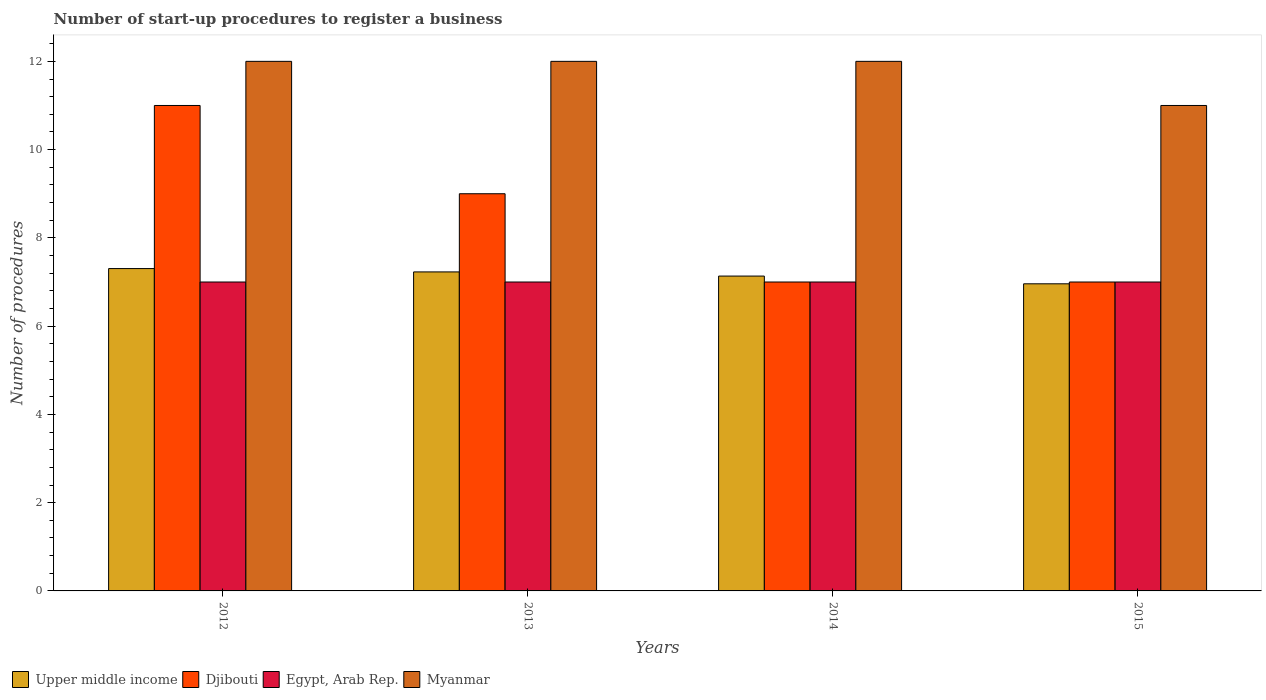How many groups of bars are there?
Provide a succinct answer. 4. What is the label of the 3rd group of bars from the left?
Give a very brief answer. 2014. In how many cases, is the number of bars for a given year not equal to the number of legend labels?
Provide a succinct answer. 0. What is the number of procedures required to register a business in Myanmar in 2012?
Ensure brevity in your answer.  12. Across all years, what is the maximum number of procedures required to register a business in Egypt, Arab Rep.?
Make the answer very short. 7. Across all years, what is the minimum number of procedures required to register a business in Myanmar?
Make the answer very short. 11. In which year was the number of procedures required to register a business in Djibouti maximum?
Offer a terse response. 2012. In which year was the number of procedures required to register a business in Myanmar minimum?
Offer a terse response. 2015. What is the total number of procedures required to register a business in Egypt, Arab Rep. in the graph?
Provide a succinct answer. 28. What is the difference between the number of procedures required to register a business in Egypt, Arab Rep. in 2013 and that in 2015?
Provide a succinct answer. 0. What is the difference between the number of procedures required to register a business in Upper middle income in 2014 and the number of procedures required to register a business in Myanmar in 2012?
Ensure brevity in your answer.  -4.87. What is the average number of procedures required to register a business in Egypt, Arab Rep. per year?
Provide a succinct answer. 7. In how many years, is the number of procedures required to register a business in Egypt, Arab Rep. greater than 6.4?
Your answer should be compact. 4. What is the ratio of the number of procedures required to register a business in Myanmar in 2013 to that in 2015?
Provide a short and direct response. 1.09. Is the difference between the number of procedures required to register a business in Djibouti in 2012 and 2014 greater than the difference between the number of procedures required to register a business in Egypt, Arab Rep. in 2012 and 2014?
Ensure brevity in your answer.  Yes. What is the difference between the highest and the second highest number of procedures required to register a business in Upper middle income?
Provide a short and direct response. 0.08. In how many years, is the number of procedures required to register a business in Myanmar greater than the average number of procedures required to register a business in Myanmar taken over all years?
Provide a succinct answer. 3. Is the sum of the number of procedures required to register a business in Egypt, Arab Rep. in 2012 and 2015 greater than the maximum number of procedures required to register a business in Myanmar across all years?
Offer a very short reply. Yes. What does the 1st bar from the left in 2014 represents?
Ensure brevity in your answer.  Upper middle income. What does the 3rd bar from the right in 2014 represents?
Give a very brief answer. Djibouti. How many bars are there?
Ensure brevity in your answer.  16. How many years are there in the graph?
Ensure brevity in your answer.  4. What is the difference between two consecutive major ticks on the Y-axis?
Your answer should be very brief. 2. Does the graph contain grids?
Give a very brief answer. No. Where does the legend appear in the graph?
Your response must be concise. Bottom left. What is the title of the graph?
Provide a short and direct response. Number of start-up procedures to register a business. What is the label or title of the Y-axis?
Keep it short and to the point. Number of procedures. What is the Number of procedures of Upper middle income in 2012?
Give a very brief answer. 7.3. What is the Number of procedures in Myanmar in 2012?
Provide a short and direct response. 12. What is the Number of procedures of Upper middle income in 2013?
Your answer should be very brief. 7.23. What is the Number of procedures in Djibouti in 2013?
Offer a terse response. 9. What is the Number of procedures of Egypt, Arab Rep. in 2013?
Your answer should be compact. 7. What is the Number of procedures of Upper middle income in 2014?
Give a very brief answer. 7.13. What is the Number of procedures in Djibouti in 2014?
Offer a terse response. 7. What is the Number of procedures of Myanmar in 2014?
Make the answer very short. 12. What is the Number of procedures in Upper middle income in 2015?
Keep it short and to the point. 6.96. What is the Number of procedures of Egypt, Arab Rep. in 2015?
Keep it short and to the point. 7. What is the Number of procedures in Myanmar in 2015?
Your answer should be very brief. 11. Across all years, what is the maximum Number of procedures in Upper middle income?
Offer a terse response. 7.3. Across all years, what is the maximum Number of procedures of Egypt, Arab Rep.?
Provide a succinct answer. 7. Across all years, what is the maximum Number of procedures in Myanmar?
Your answer should be compact. 12. Across all years, what is the minimum Number of procedures in Upper middle income?
Your answer should be compact. 6.96. Across all years, what is the minimum Number of procedures of Djibouti?
Your response must be concise. 7. Across all years, what is the minimum Number of procedures of Myanmar?
Provide a succinct answer. 11. What is the total Number of procedures in Upper middle income in the graph?
Provide a short and direct response. 28.63. What is the total Number of procedures in Egypt, Arab Rep. in the graph?
Your answer should be very brief. 28. What is the difference between the Number of procedures in Upper middle income in 2012 and that in 2013?
Give a very brief answer. 0.08. What is the difference between the Number of procedures of Upper middle income in 2012 and that in 2014?
Ensure brevity in your answer.  0.17. What is the difference between the Number of procedures of Egypt, Arab Rep. in 2012 and that in 2014?
Provide a short and direct response. 0. What is the difference between the Number of procedures in Myanmar in 2012 and that in 2014?
Your answer should be compact. 0. What is the difference between the Number of procedures of Upper middle income in 2012 and that in 2015?
Offer a terse response. 0.35. What is the difference between the Number of procedures in Djibouti in 2012 and that in 2015?
Your answer should be compact. 4. What is the difference between the Number of procedures in Egypt, Arab Rep. in 2012 and that in 2015?
Your answer should be very brief. 0. What is the difference between the Number of procedures in Upper middle income in 2013 and that in 2014?
Your answer should be very brief. 0.09. What is the difference between the Number of procedures in Djibouti in 2013 and that in 2014?
Ensure brevity in your answer.  2. What is the difference between the Number of procedures of Upper middle income in 2013 and that in 2015?
Offer a very short reply. 0.27. What is the difference between the Number of procedures of Djibouti in 2013 and that in 2015?
Your answer should be compact. 2. What is the difference between the Number of procedures of Myanmar in 2013 and that in 2015?
Give a very brief answer. 1. What is the difference between the Number of procedures in Upper middle income in 2014 and that in 2015?
Your answer should be compact. 0.18. What is the difference between the Number of procedures of Egypt, Arab Rep. in 2014 and that in 2015?
Your answer should be compact. 0. What is the difference between the Number of procedures in Upper middle income in 2012 and the Number of procedures in Djibouti in 2013?
Give a very brief answer. -1.7. What is the difference between the Number of procedures in Upper middle income in 2012 and the Number of procedures in Egypt, Arab Rep. in 2013?
Your response must be concise. 0.3. What is the difference between the Number of procedures of Upper middle income in 2012 and the Number of procedures of Myanmar in 2013?
Provide a succinct answer. -4.7. What is the difference between the Number of procedures of Djibouti in 2012 and the Number of procedures of Myanmar in 2013?
Ensure brevity in your answer.  -1. What is the difference between the Number of procedures in Egypt, Arab Rep. in 2012 and the Number of procedures in Myanmar in 2013?
Provide a short and direct response. -5. What is the difference between the Number of procedures of Upper middle income in 2012 and the Number of procedures of Djibouti in 2014?
Ensure brevity in your answer.  0.3. What is the difference between the Number of procedures in Upper middle income in 2012 and the Number of procedures in Egypt, Arab Rep. in 2014?
Keep it short and to the point. 0.3. What is the difference between the Number of procedures of Upper middle income in 2012 and the Number of procedures of Myanmar in 2014?
Keep it short and to the point. -4.7. What is the difference between the Number of procedures in Djibouti in 2012 and the Number of procedures in Myanmar in 2014?
Provide a succinct answer. -1. What is the difference between the Number of procedures in Egypt, Arab Rep. in 2012 and the Number of procedures in Myanmar in 2014?
Offer a very short reply. -5. What is the difference between the Number of procedures in Upper middle income in 2012 and the Number of procedures in Djibouti in 2015?
Offer a very short reply. 0.3. What is the difference between the Number of procedures of Upper middle income in 2012 and the Number of procedures of Egypt, Arab Rep. in 2015?
Offer a terse response. 0.3. What is the difference between the Number of procedures in Upper middle income in 2012 and the Number of procedures in Myanmar in 2015?
Your response must be concise. -3.7. What is the difference between the Number of procedures in Djibouti in 2012 and the Number of procedures in Egypt, Arab Rep. in 2015?
Provide a succinct answer. 4. What is the difference between the Number of procedures of Djibouti in 2012 and the Number of procedures of Myanmar in 2015?
Make the answer very short. 0. What is the difference between the Number of procedures of Egypt, Arab Rep. in 2012 and the Number of procedures of Myanmar in 2015?
Provide a short and direct response. -4. What is the difference between the Number of procedures of Upper middle income in 2013 and the Number of procedures of Djibouti in 2014?
Provide a short and direct response. 0.23. What is the difference between the Number of procedures of Upper middle income in 2013 and the Number of procedures of Egypt, Arab Rep. in 2014?
Provide a short and direct response. 0.23. What is the difference between the Number of procedures of Upper middle income in 2013 and the Number of procedures of Myanmar in 2014?
Ensure brevity in your answer.  -4.77. What is the difference between the Number of procedures of Djibouti in 2013 and the Number of procedures of Egypt, Arab Rep. in 2014?
Ensure brevity in your answer.  2. What is the difference between the Number of procedures of Upper middle income in 2013 and the Number of procedures of Djibouti in 2015?
Your response must be concise. 0.23. What is the difference between the Number of procedures of Upper middle income in 2013 and the Number of procedures of Egypt, Arab Rep. in 2015?
Your answer should be very brief. 0.23. What is the difference between the Number of procedures of Upper middle income in 2013 and the Number of procedures of Myanmar in 2015?
Your answer should be compact. -3.77. What is the difference between the Number of procedures in Djibouti in 2013 and the Number of procedures in Myanmar in 2015?
Your answer should be very brief. -2. What is the difference between the Number of procedures in Upper middle income in 2014 and the Number of procedures in Djibouti in 2015?
Ensure brevity in your answer.  0.13. What is the difference between the Number of procedures of Upper middle income in 2014 and the Number of procedures of Egypt, Arab Rep. in 2015?
Keep it short and to the point. 0.13. What is the difference between the Number of procedures in Upper middle income in 2014 and the Number of procedures in Myanmar in 2015?
Offer a very short reply. -3.87. What is the difference between the Number of procedures in Djibouti in 2014 and the Number of procedures in Egypt, Arab Rep. in 2015?
Make the answer very short. 0. What is the average Number of procedures in Upper middle income per year?
Make the answer very short. 7.16. What is the average Number of procedures in Egypt, Arab Rep. per year?
Offer a terse response. 7. What is the average Number of procedures of Myanmar per year?
Your response must be concise. 11.75. In the year 2012, what is the difference between the Number of procedures in Upper middle income and Number of procedures in Djibouti?
Provide a short and direct response. -3.7. In the year 2012, what is the difference between the Number of procedures in Upper middle income and Number of procedures in Egypt, Arab Rep.?
Provide a short and direct response. 0.3. In the year 2012, what is the difference between the Number of procedures of Upper middle income and Number of procedures of Myanmar?
Keep it short and to the point. -4.7. In the year 2012, what is the difference between the Number of procedures of Djibouti and Number of procedures of Egypt, Arab Rep.?
Provide a succinct answer. 4. In the year 2012, what is the difference between the Number of procedures of Djibouti and Number of procedures of Myanmar?
Your response must be concise. -1. In the year 2013, what is the difference between the Number of procedures in Upper middle income and Number of procedures in Djibouti?
Offer a terse response. -1.77. In the year 2013, what is the difference between the Number of procedures of Upper middle income and Number of procedures of Egypt, Arab Rep.?
Your answer should be very brief. 0.23. In the year 2013, what is the difference between the Number of procedures in Upper middle income and Number of procedures in Myanmar?
Provide a succinct answer. -4.77. In the year 2013, what is the difference between the Number of procedures of Djibouti and Number of procedures of Myanmar?
Give a very brief answer. -3. In the year 2013, what is the difference between the Number of procedures in Egypt, Arab Rep. and Number of procedures in Myanmar?
Your answer should be compact. -5. In the year 2014, what is the difference between the Number of procedures of Upper middle income and Number of procedures of Djibouti?
Your response must be concise. 0.13. In the year 2014, what is the difference between the Number of procedures in Upper middle income and Number of procedures in Egypt, Arab Rep.?
Offer a very short reply. 0.13. In the year 2014, what is the difference between the Number of procedures in Upper middle income and Number of procedures in Myanmar?
Ensure brevity in your answer.  -4.87. In the year 2014, what is the difference between the Number of procedures in Djibouti and Number of procedures in Myanmar?
Make the answer very short. -5. In the year 2014, what is the difference between the Number of procedures of Egypt, Arab Rep. and Number of procedures of Myanmar?
Offer a terse response. -5. In the year 2015, what is the difference between the Number of procedures of Upper middle income and Number of procedures of Djibouti?
Your answer should be very brief. -0.04. In the year 2015, what is the difference between the Number of procedures in Upper middle income and Number of procedures in Egypt, Arab Rep.?
Your answer should be very brief. -0.04. In the year 2015, what is the difference between the Number of procedures of Upper middle income and Number of procedures of Myanmar?
Provide a short and direct response. -4.04. In the year 2015, what is the difference between the Number of procedures in Djibouti and Number of procedures in Myanmar?
Give a very brief answer. -4. What is the ratio of the Number of procedures of Upper middle income in 2012 to that in 2013?
Your answer should be very brief. 1.01. What is the ratio of the Number of procedures in Djibouti in 2012 to that in 2013?
Keep it short and to the point. 1.22. What is the ratio of the Number of procedures of Egypt, Arab Rep. in 2012 to that in 2013?
Ensure brevity in your answer.  1. What is the ratio of the Number of procedures in Myanmar in 2012 to that in 2013?
Your answer should be compact. 1. What is the ratio of the Number of procedures of Upper middle income in 2012 to that in 2014?
Keep it short and to the point. 1.02. What is the ratio of the Number of procedures of Djibouti in 2012 to that in 2014?
Offer a very short reply. 1.57. What is the ratio of the Number of procedures of Upper middle income in 2012 to that in 2015?
Your response must be concise. 1.05. What is the ratio of the Number of procedures in Djibouti in 2012 to that in 2015?
Your answer should be very brief. 1.57. What is the ratio of the Number of procedures of Upper middle income in 2013 to that in 2014?
Offer a terse response. 1.01. What is the ratio of the Number of procedures in Egypt, Arab Rep. in 2013 to that in 2014?
Make the answer very short. 1. What is the ratio of the Number of procedures in Upper middle income in 2013 to that in 2015?
Ensure brevity in your answer.  1.04. What is the ratio of the Number of procedures in Djibouti in 2013 to that in 2015?
Your answer should be compact. 1.29. What is the ratio of the Number of procedures in Upper middle income in 2014 to that in 2015?
Make the answer very short. 1.03. What is the ratio of the Number of procedures in Djibouti in 2014 to that in 2015?
Make the answer very short. 1. What is the ratio of the Number of procedures of Egypt, Arab Rep. in 2014 to that in 2015?
Your answer should be compact. 1. What is the difference between the highest and the second highest Number of procedures in Upper middle income?
Provide a short and direct response. 0.08. What is the difference between the highest and the second highest Number of procedures in Djibouti?
Keep it short and to the point. 2. What is the difference between the highest and the lowest Number of procedures of Upper middle income?
Offer a terse response. 0.35. What is the difference between the highest and the lowest Number of procedures in Myanmar?
Give a very brief answer. 1. 